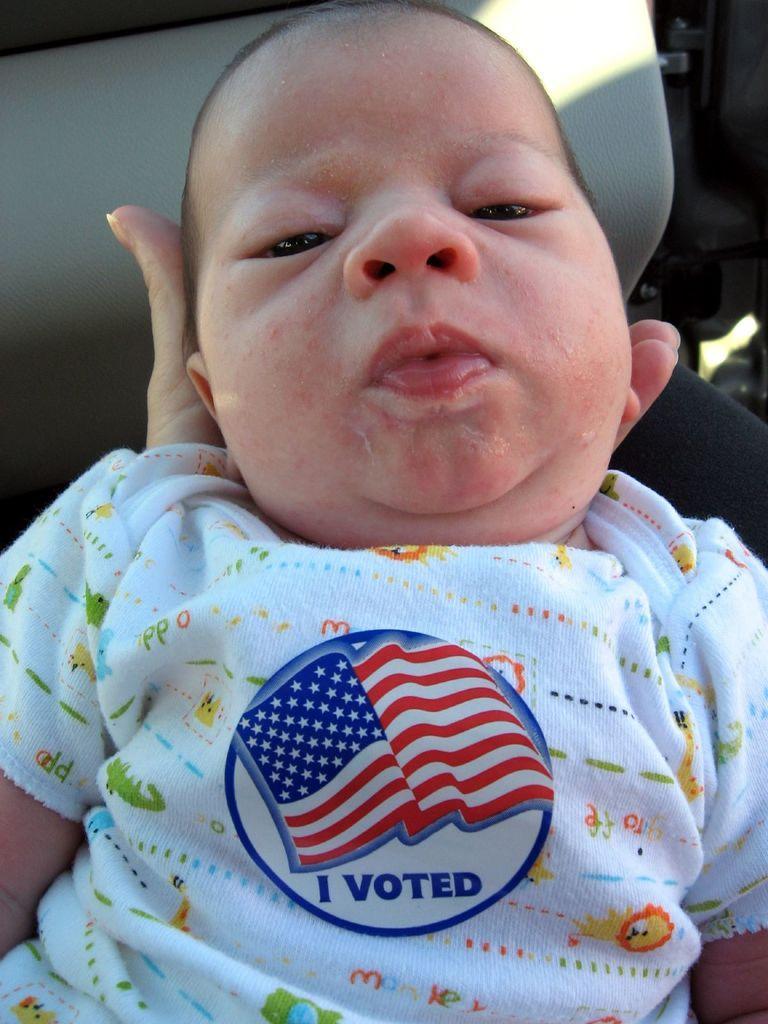Please provide a concise description of this image. In the image we can see there is a person holding an infant in her hand and the infant is wearing a t-shirt on which it's written ¨I Voted¨. 